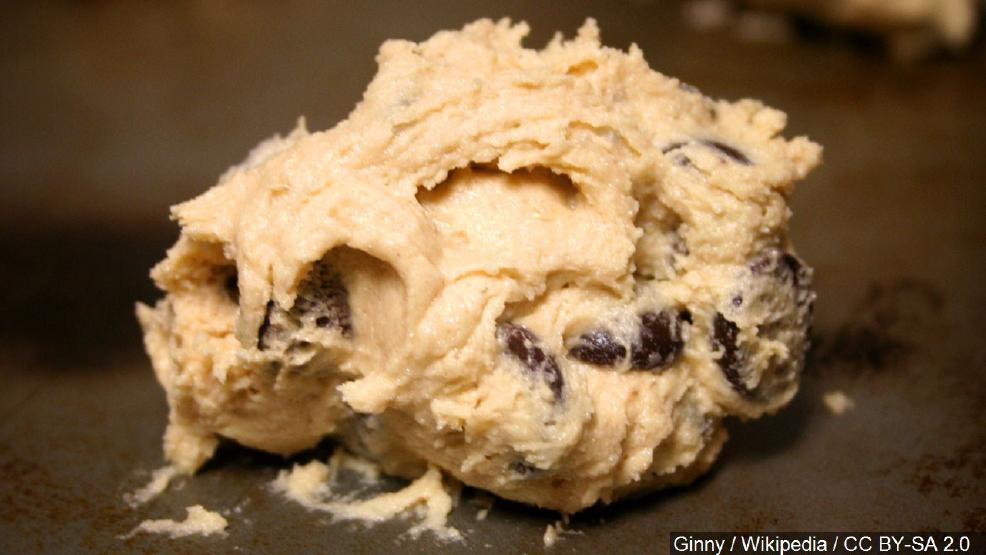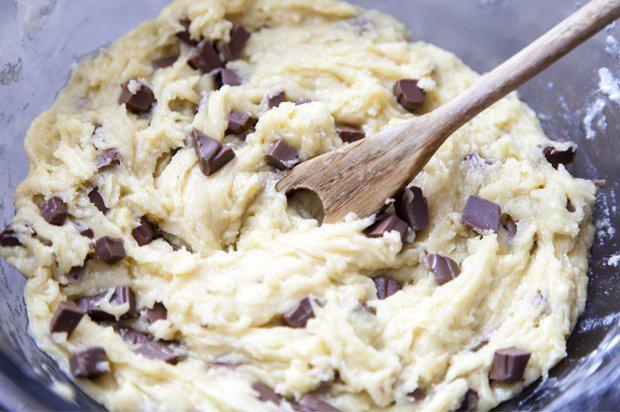The first image is the image on the left, the second image is the image on the right. For the images displayed, is the sentence "There are multiple raw cookies on a baking sheet." factually correct? Answer yes or no. No. The first image is the image on the left, the second image is the image on the right. Assess this claim about the two images: "The right image features mounds of raw cookie dough in rows with a metal sheet under them.". Correct or not? Answer yes or no. No. 